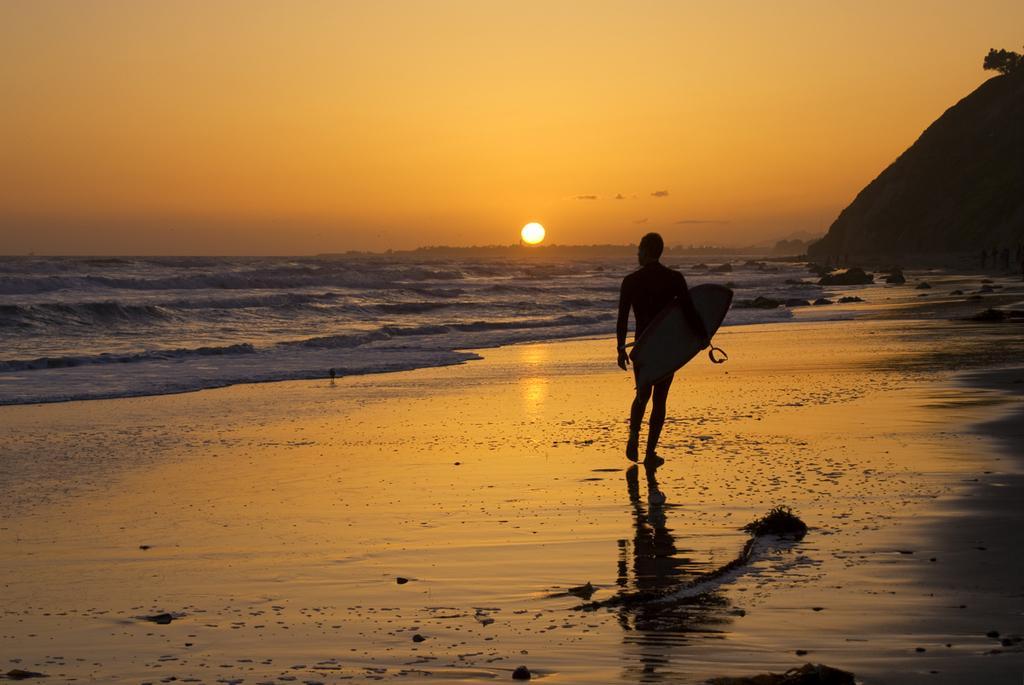Describe this image in one or two sentences. The picture is clicked near a sea. A lady walking with an object in her hand. The tides are beautiful in the background and the sun is setting. There is also a hill in the right side of the image. 